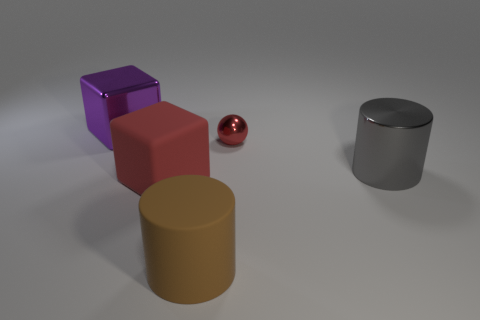Subtract all cubes. How many objects are left? 3 Add 4 big red things. How many objects exist? 9 Subtract all red blocks. Subtract all tiny red metallic things. How many objects are left? 3 Add 1 shiny cylinders. How many shiny cylinders are left? 2 Add 4 big brown matte cylinders. How many big brown matte cylinders exist? 5 Subtract 1 red spheres. How many objects are left? 4 